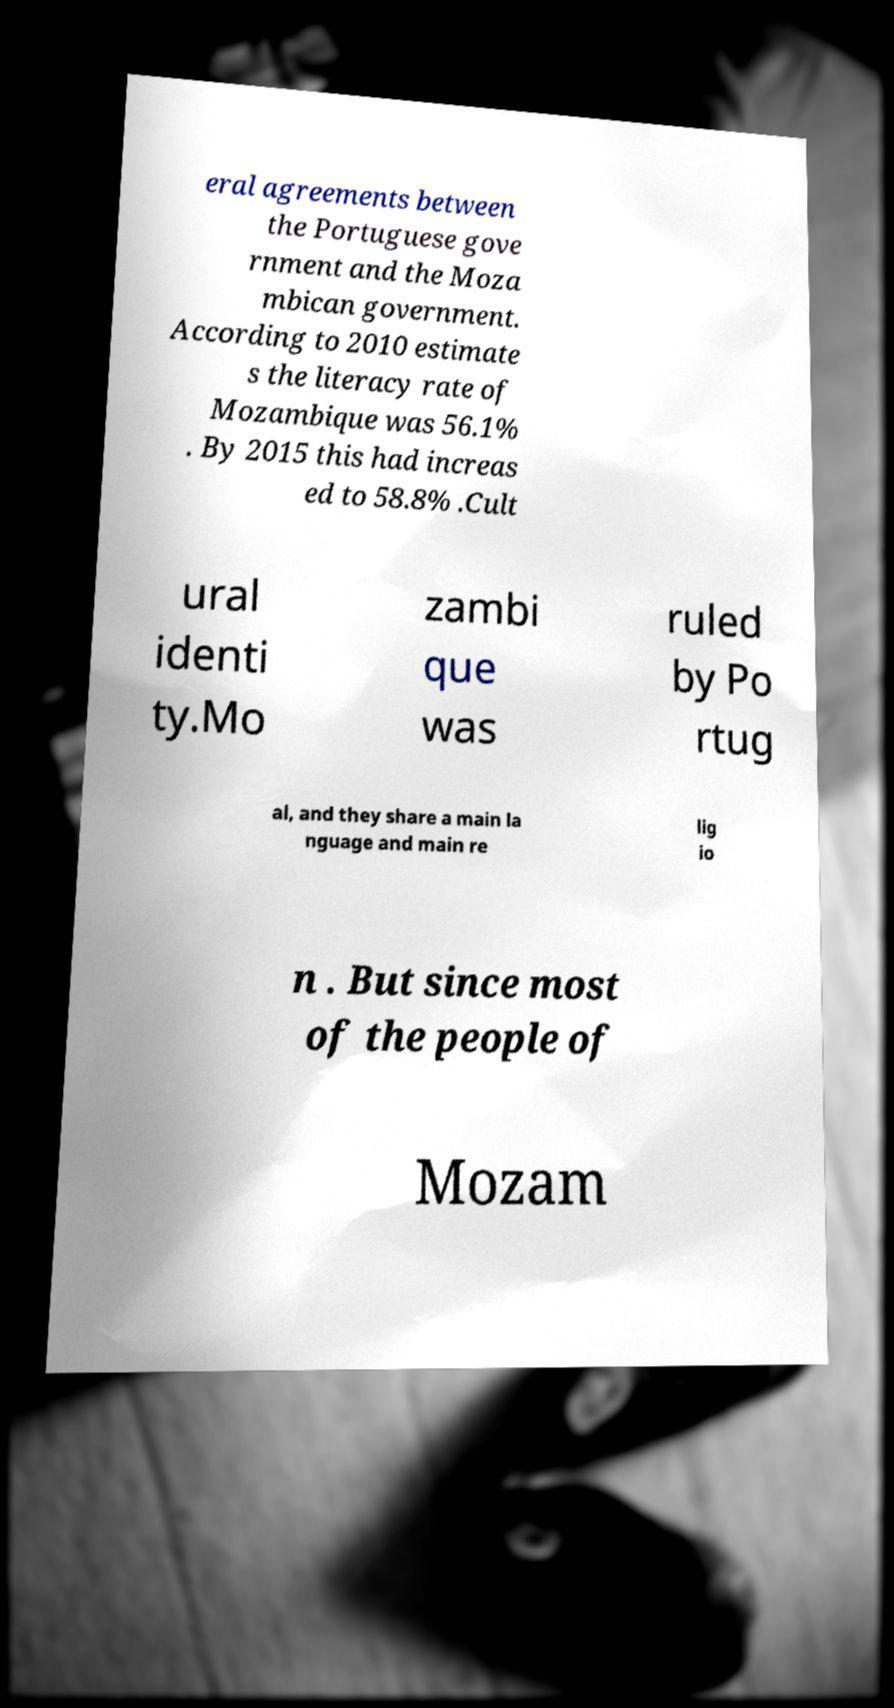Please read and relay the text visible in this image. What does it say? eral agreements between the Portuguese gove rnment and the Moza mbican government. According to 2010 estimate s the literacy rate of Mozambique was 56.1% . By 2015 this had increas ed to 58.8% .Cult ural identi ty.Mo zambi que was ruled by Po rtug al, and they share a main la nguage and main re lig io n . But since most of the people of Mozam 